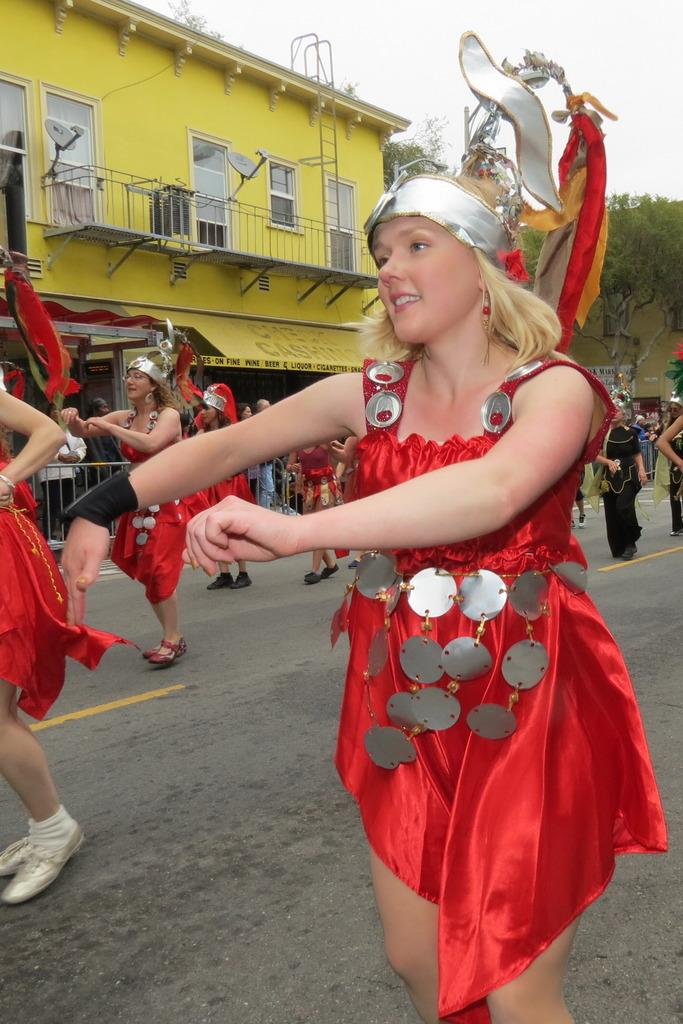What are the people in the image doing? The people in the image are wearing crowns and performing. Where is the performance taking place? The performance is taking place on the road. What else can be seen in the image besides the performance? There are people on the pavement, fences, a building with windows, and trees present in the image. What is the purpose of the calendar in the image? There is no calendar present in the image. What industry do the people in the image belong to? The provided facts do not mention any specific industry or occupation for the people in the image. 